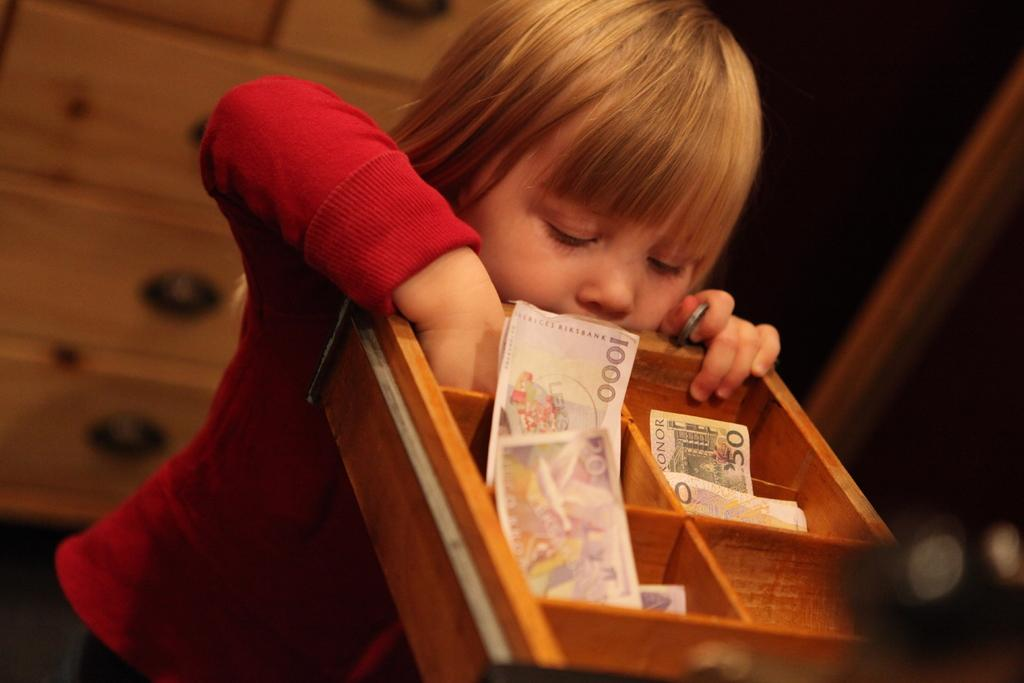What is the main subject of the image? There is a child in the image. Can you describe the child's appearance? The child is wearing clothes. What object can be seen in the image besides the child? There is a drawer in the image. What is inside the drawer? Money is present in the drawer. How would you describe the background of the image? The background of the image is blurred. What type of glass object is being used by the child in the image? There is no glass object present in the image. Can you tell me how many wrens are visible in the image? There are no wrens present in the image. 